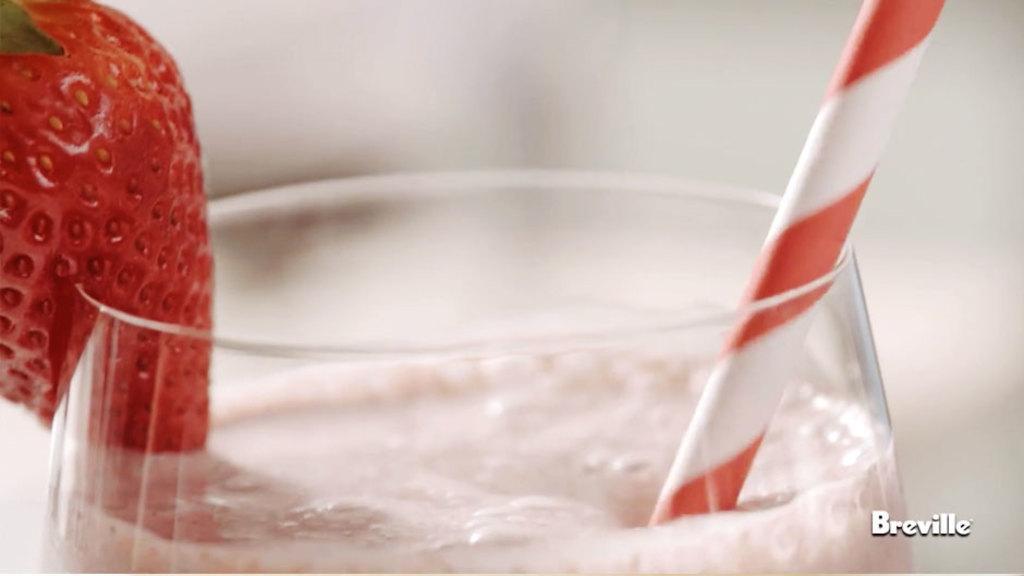Could you give a brief overview of what you see in this image? In the image in the center, we can see one glass. In the glass, we can see some juice, strawberry and straw. In the bottom right of the image, there is a watermark. 